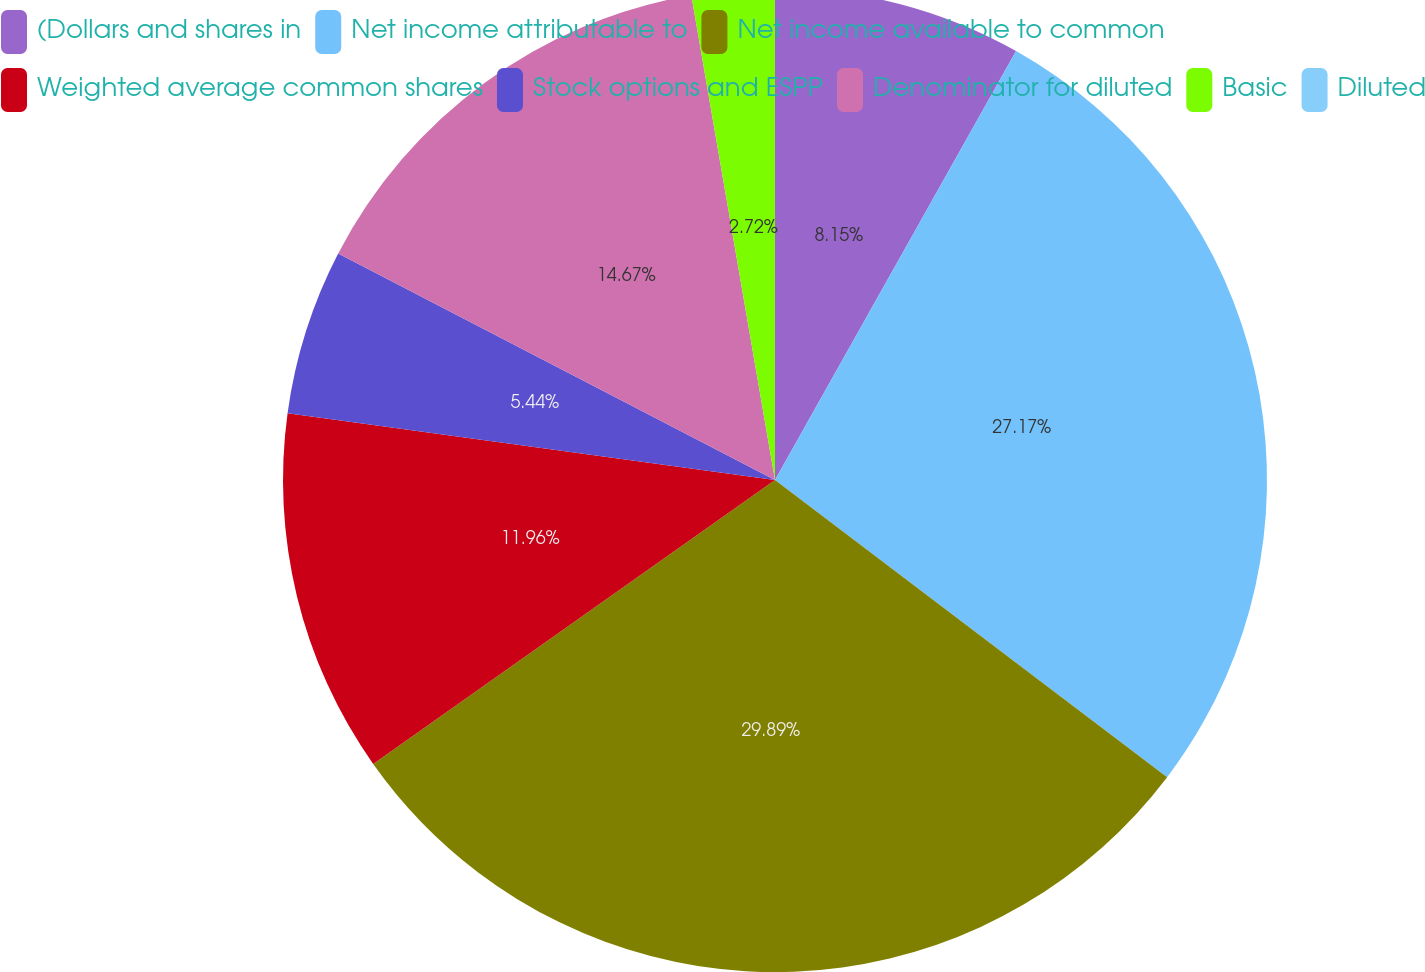<chart> <loc_0><loc_0><loc_500><loc_500><pie_chart><fcel>(Dollars and shares in<fcel>Net income attributable to<fcel>Net income available to common<fcel>Weighted average common shares<fcel>Stock options and ESPP<fcel>Denominator for diluted<fcel>Basic<fcel>Diluted<nl><fcel>8.15%<fcel>27.17%<fcel>29.89%<fcel>11.96%<fcel>5.44%<fcel>14.67%<fcel>2.72%<fcel>0.0%<nl></chart> 